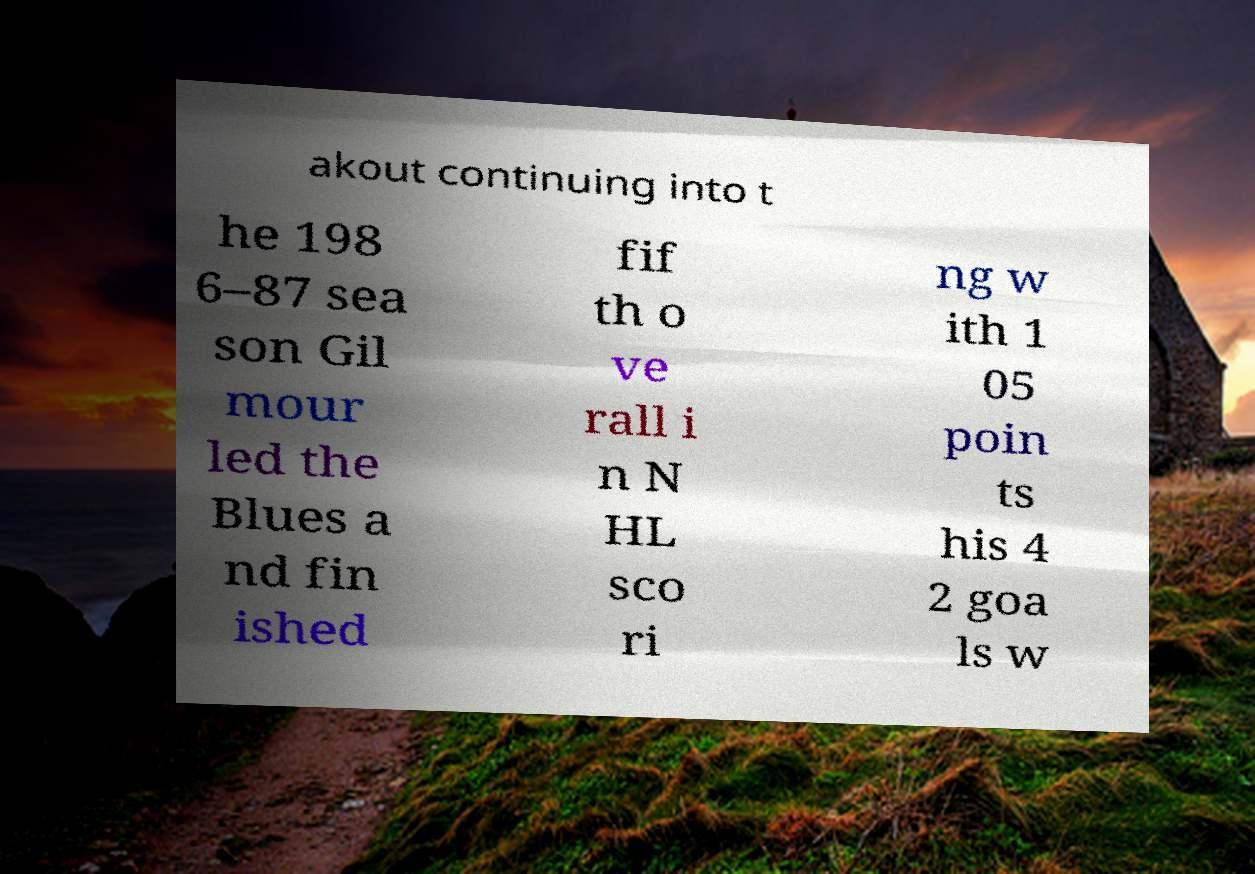Can you accurately transcribe the text from the provided image for me? akout continuing into t he 198 6–87 sea son Gil mour led the Blues a nd fin ished fif th o ve rall i n N HL sco ri ng w ith 1 05 poin ts his 4 2 goa ls w 